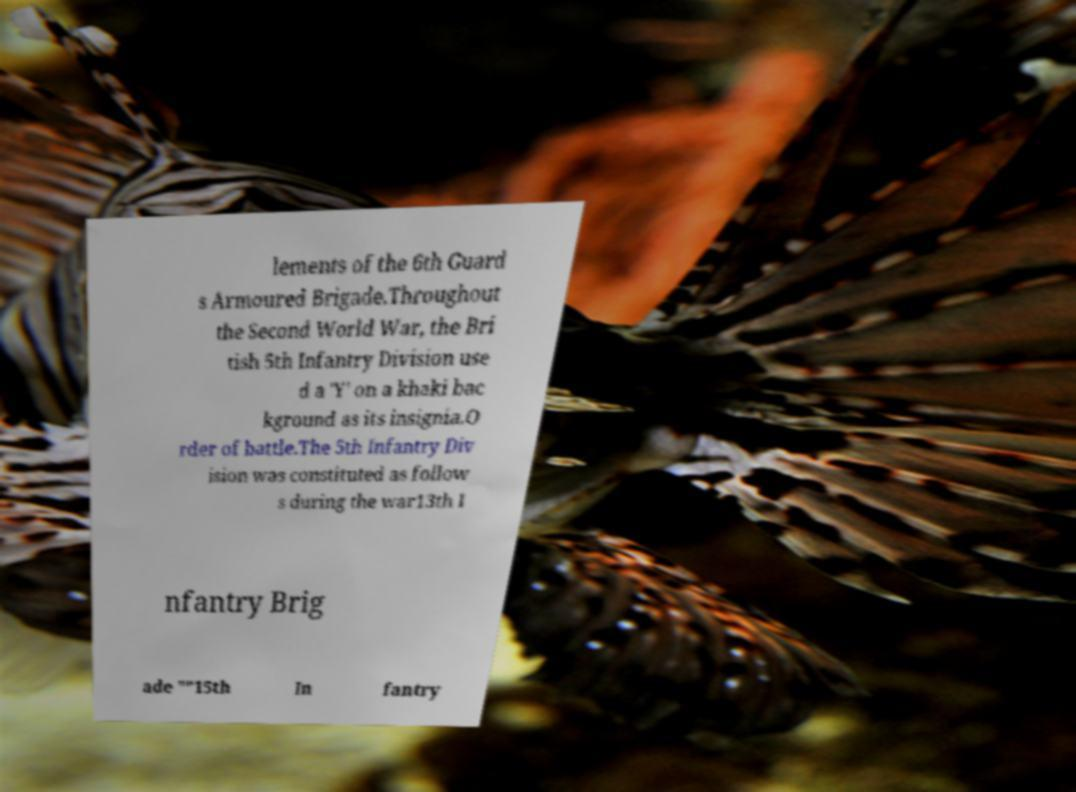Can you accurately transcribe the text from the provided image for me? lements of the 6th Guard s Armoured Brigade.Throughout the Second World War, the Bri tish 5th Infantry Division use d a 'Y' on a khaki bac kground as its insignia.O rder of battle.The 5th Infantry Div ision was constituted as follow s during the war13th I nfantry Brig ade ""15th In fantry 